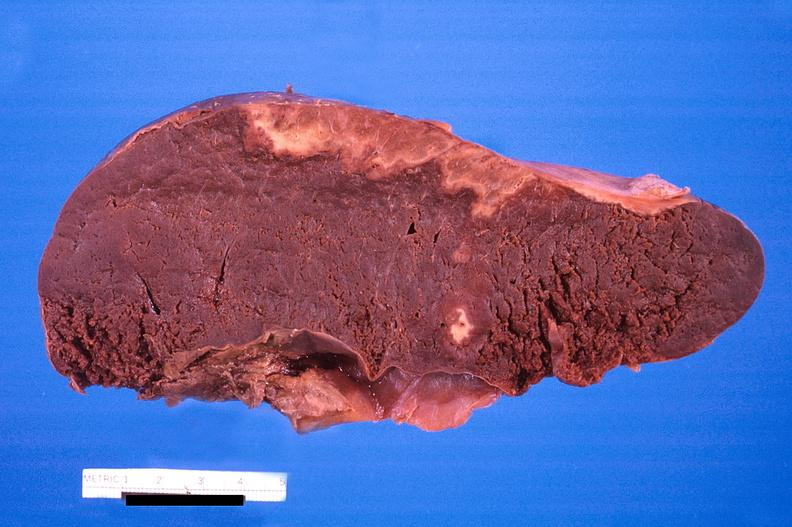does this image show spleen, infarcts, disseminated intravascular coagulation?
Answer the question using a single word or phrase. Yes 